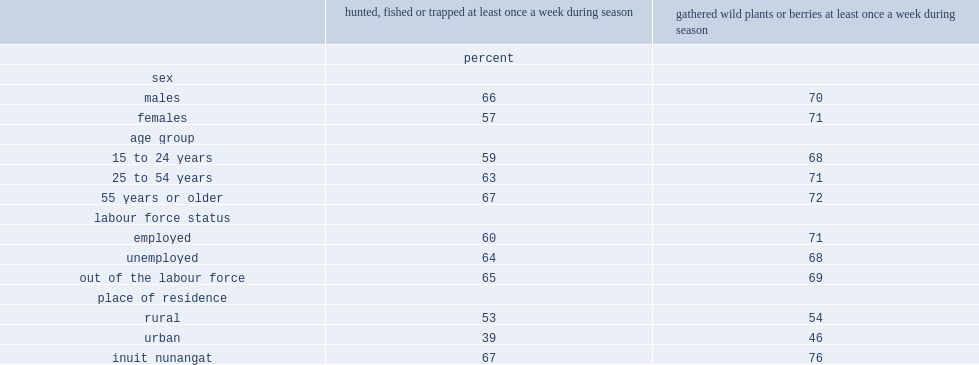What was the percentage of inuit nunangat who had hunted, fished or trapped had done so at least once a wee?k. 67.0. Who had a higher percentage of higher frequency hunting, fishing or trapping,males or females? Males. 